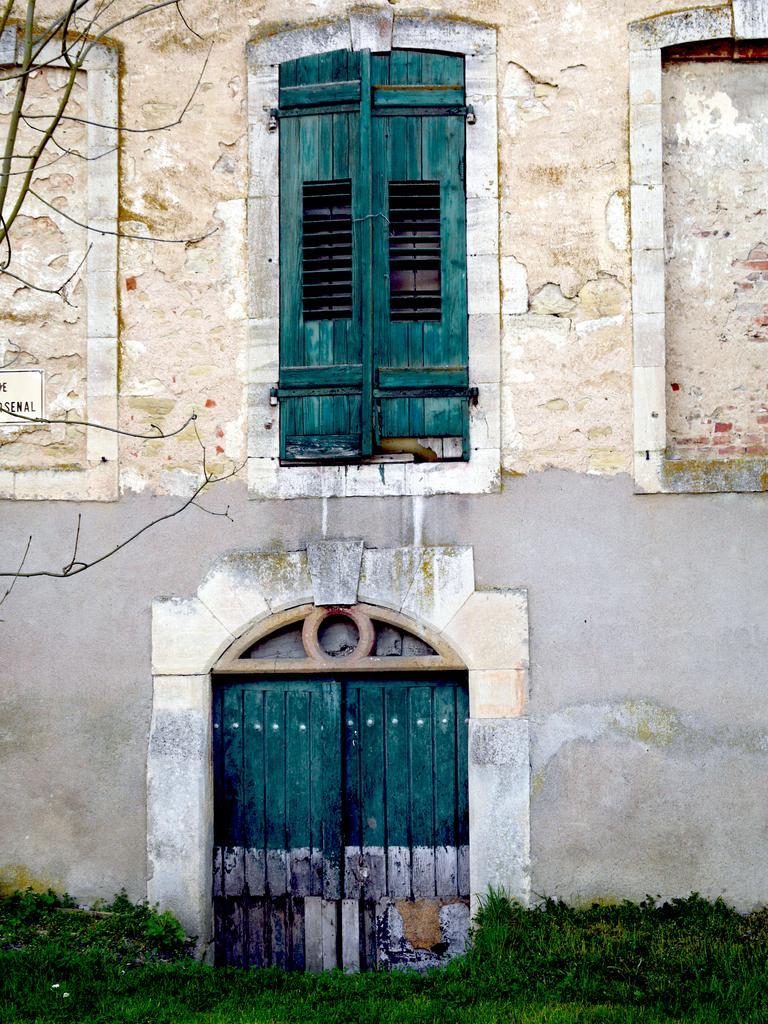How would you summarize this image in a sentence or two? In this picture there is a building which has two wooden doors which are in green color and there is a greenery ground in front of it. 